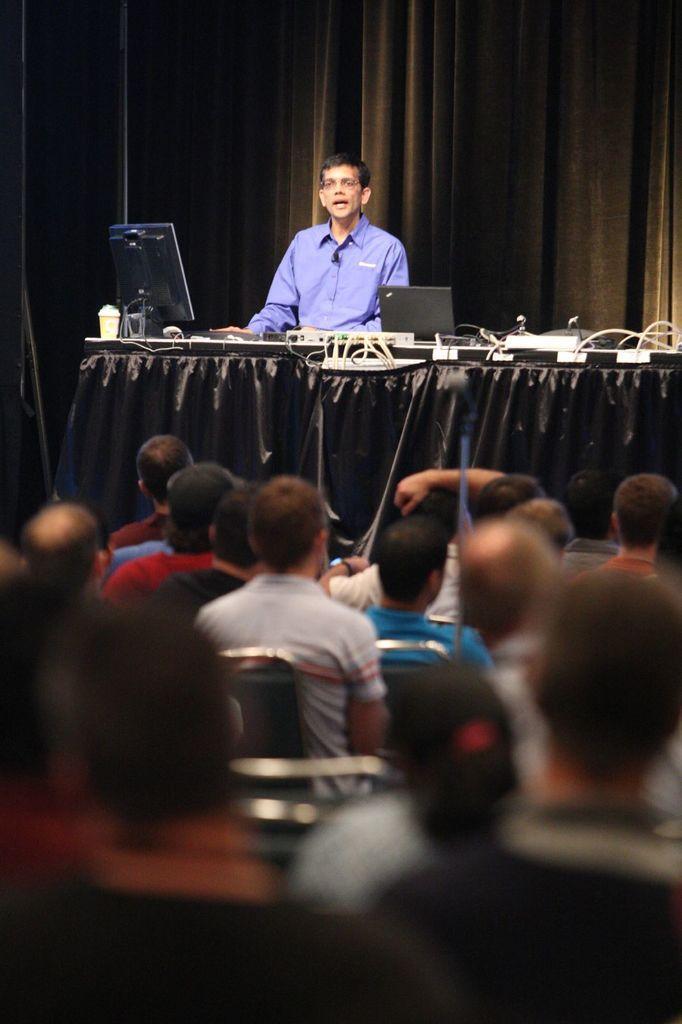In one or two sentences, can you explain what this image depicts? There are persons sitting. In front of them, there is a person in a blue color shirt, sitting and speaking. In front of this person, there is a table, on which there is a screen, a laptop and there are other objects. In the background, there is a curtain and the background is dark in color. 